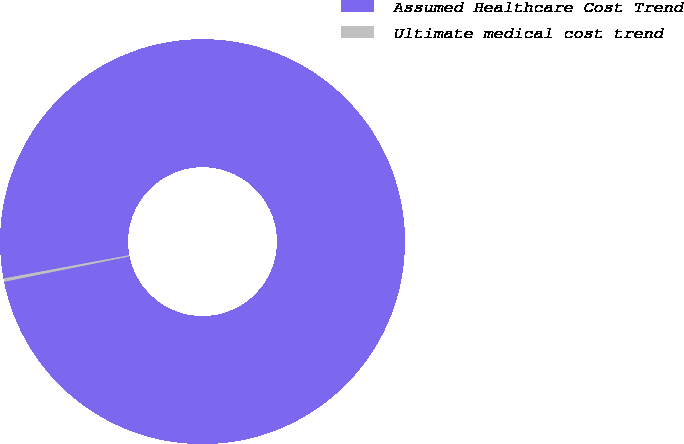Convert chart to OTSL. <chart><loc_0><loc_0><loc_500><loc_500><pie_chart><fcel>Assumed Healthcare Cost Trend<fcel>Ultimate medical cost trend<nl><fcel>99.75%<fcel>0.25%<nl></chart> 